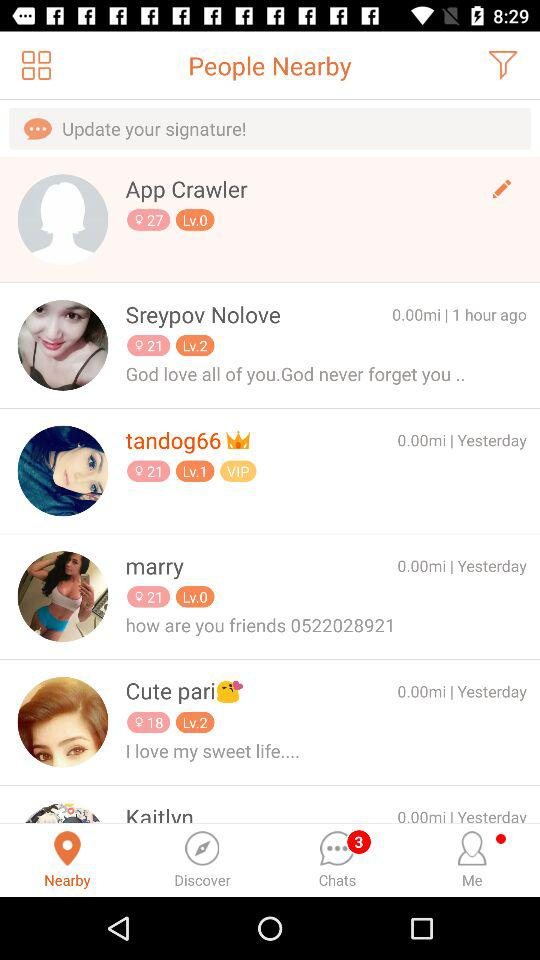At what level is the "Cute pari"? "Cute pari" is at level 2. 